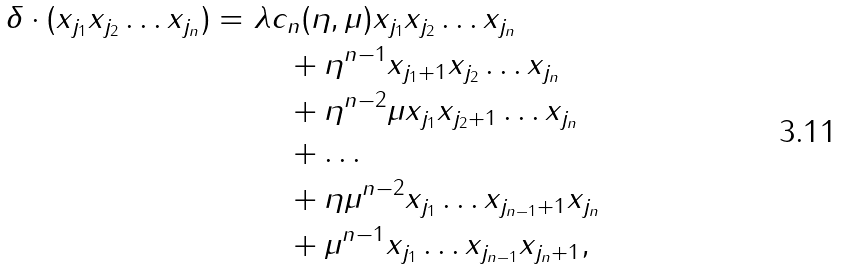<formula> <loc_0><loc_0><loc_500><loc_500>\delta \cdot ( x _ { j _ { 1 } } x _ { j _ { 2 } } \dots x _ { j _ { n } } ) = \ & \lambda c _ { n } ( \eta , \mu ) x _ { j _ { 1 } } x _ { j _ { 2 } } \dots x _ { j _ { n } } \\ & \quad + \eta ^ { n - 1 } x _ { j _ { 1 } + 1 } x _ { j _ { 2 } } \dots x _ { j _ { n } } \\ & \quad + \eta ^ { n - 2 } \mu x _ { j _ { 1 } } x _ { j _ { 2 } + 1 } \dots x _ { j _ { n } } \\ & \quad + \dots \\ & \quad + \eta \mu ^ { n - 2 } x _ { j _ { 1 } } \dots x _ { j _ { n - 1 } + 1 } x _ { j _ { n } } \\ & \quad + \mu ^ { n - 1 } x _ { j _ { 1 } } \dots x _ { j _ { n - 1 } } x _ { j _ { n } + 1 } ,</formula> 